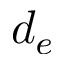Convert formula to latex. <formula><loc_0><loc_0><loc_500><loc_500>d _ { e }</formula> 